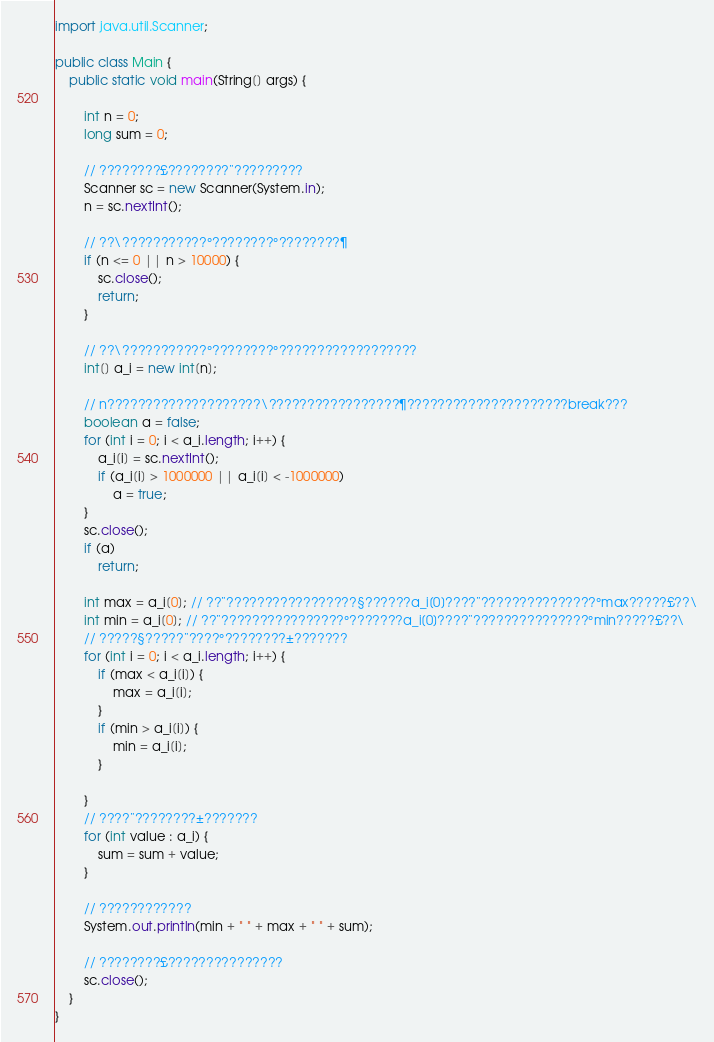Convert code to text. <code><loc_0><loc_0><loc_500><loc_500><_Java_>
import java.util.Scanner;

public class Main {
	public static void main(String[] args) {

		int n = 0;
		long sum = 0;

		// ????????£????????¨?????????
		Scanner sc = new Scanner(System.in);
		n = sc.nextInt();

		// ??\???????????°????????°????????¶
		if (n <= 0 || n > 10000) {
			sc.close();
			return;
		}

		// ??\???????????°????????°??????????????????
		int[] a_i = new int[n];

		// n????????????????????\?????????????????¶?????????????????????break???
		boolean a = false;
		for (int i = 0; i < a_i.length; i++) {
			a_i[i] = sc.nextInt();
			if (a_i[i] > 1000000 || a_i[i] < -1000000)
				a = true;
		}
		sc.close();
		if (a)
			return;

		int max = a_i[0]; // ??¨?????????????????§??????a_i[0]????¨???????????????°max?????£??\
		int min = a_i[0]; // ??¨????????????????°???????a_i[0]????¨???????????????°min?????£??\
		// ?????§?????¨????°????????±???????
		for (int i = 0; i < a_i.length; i++) {
			if (max < a_i[i]) {
				max = a_i[i];
			}
			if (min > a_i[i]) {
				min = a_i[i];
			}

		}
		// ????¨????????±???????
		for (int value : a_i) {
			sum = sum + value;
		}

		// ????????????
		System.out.println(min + " " + max + " " + sum);

		// ????????£???????????????
		sc.close();
	}
}</code> 